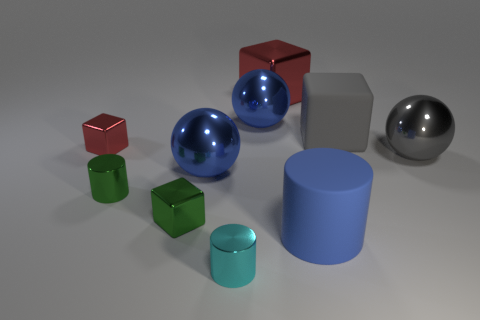Subtract all tiny green cylinders. How many cylinders are left? 2 Subtract all gray spheres. How many spheres are left? 2 Subtract all gray spheres. Subtract all blue cylinders. How many spheres are left? 2 Subtract all large gray cubes. Subtract all large cylinders. How many objects are left? 8 Add 9 large matte cylinders. How many large matte cylinders are left? 10 Add 7 large gray matte blocks. How many large gray matte blocks exist? 8 Subtract 0 gray cylinders. How many objects are left? 10 Subtract all balls. How many objects are left? 7 Subtract 3 cylinders. How many cylinders are left? 0 Subtract all green spheres. How many blue cubes are left? 0 